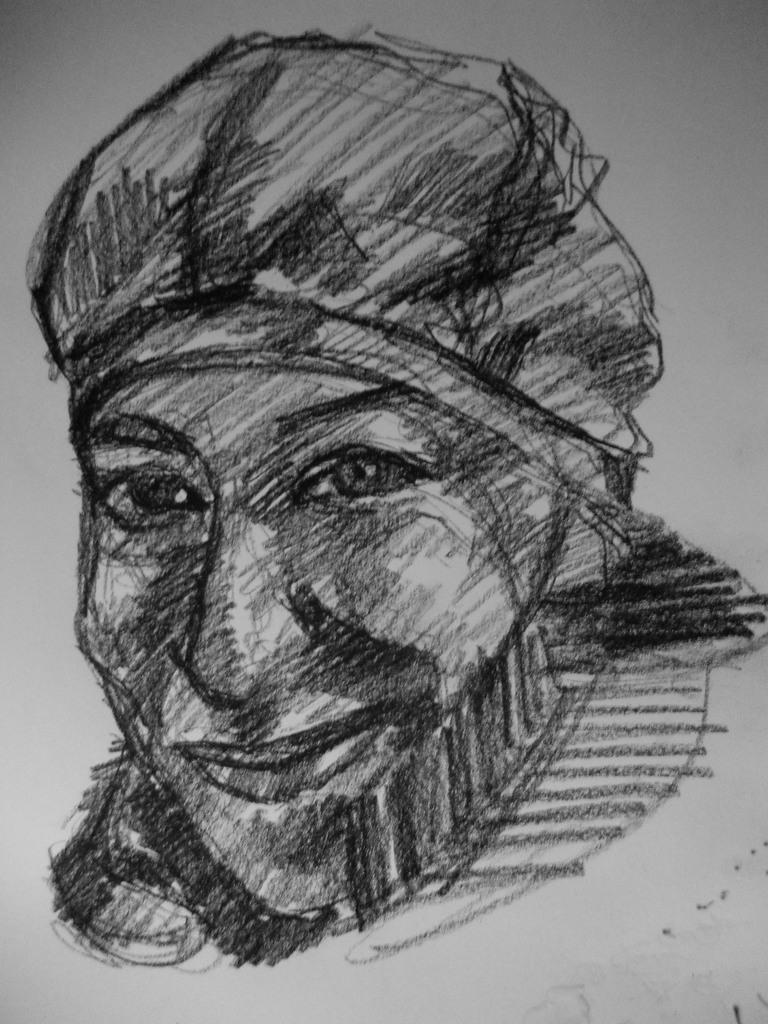What is depicted on the paper in the image? There is a paper with art in the image. What medium was used to create the art on the paper? The art is done with a pencil on the paper. How many beads are used in the art on the paper? There are no beads present in the image; the art is done with a pencil on the paper. What type of tools would a carpenter need to create the art on the paper? A carpenter typically works with wood and tools like saws and hammers, which are not relevant to creating art on paper with a pencil. 